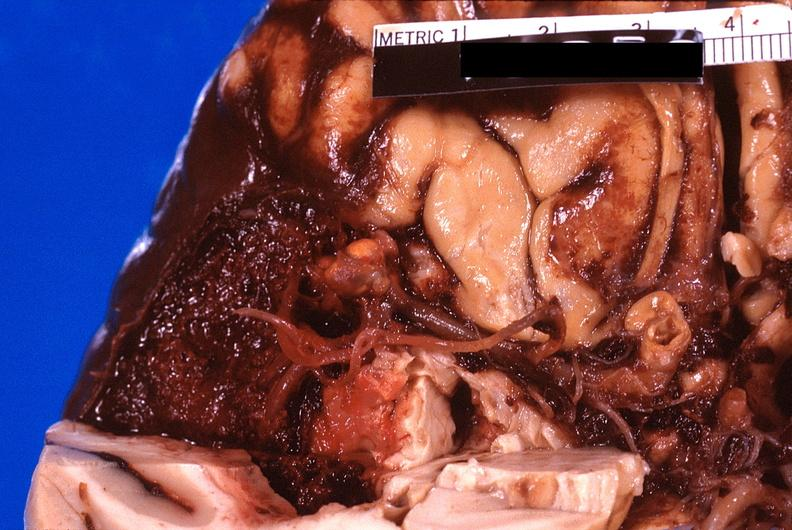what does this image show?
Answer the question using a single word or phrase. Brain 